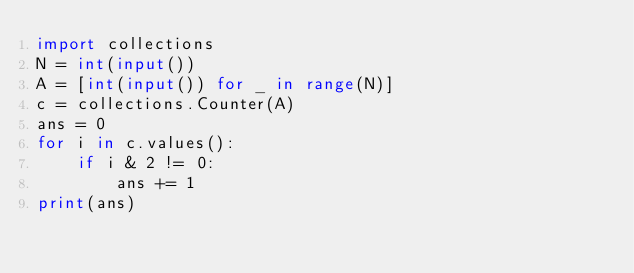<code> <loc_0><loc_0><loc_500><loc_500><_Python_>import collections
N = int(input())
A = [int(input()) for _ in range(N)]
c = collections.Counter(A)
ans = 0
for i in c.values():
    if i & 2 != 0:
        ans += 1
print(ans) </code> 